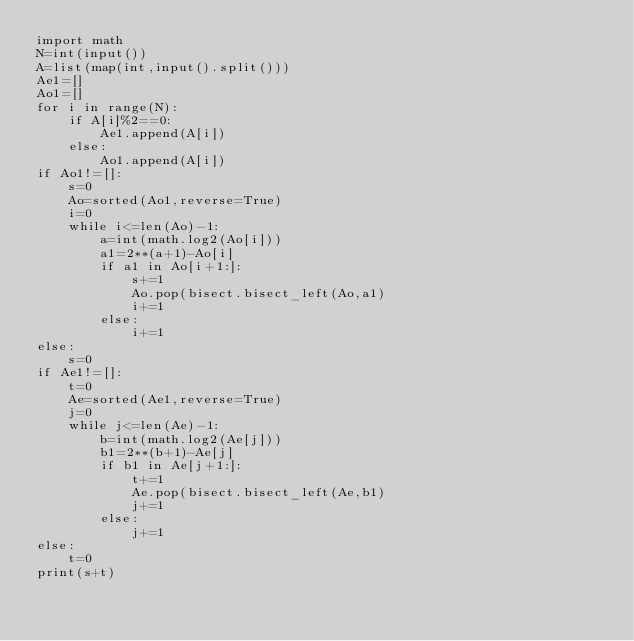<code> <loc_0><loc_0><loc_500><loc_500><_Python_>import math
N=int(input())
A=list(map(int,input().split()))
Ae1=[]
Ao1=[]
for i in range(N):
    if A[i]%2==0:
        Ae1.append(A[i])
    else:
        Ao1.append(A[i])
if Ao1!=[]:
    s=0
    Ao=sorted(Ao1,reverse=True)
    i=0
    while i<=len(Ao)-1:
        a=int(math.log2(Ao[i]))
        a1=2**(a+1)-Ao[i]
        if a1 in Ao[i+1:]:
            s+=1
            Ao.pop(bisect.bisect_left(Ao,a1)
            i+=1
        else:
            i+=1
else:
    s=0
if Ae1!=[]:
    t=0
    Ae=sorted(Ae1,reverse=True)
    j=0
    while j<=len(Ae)-1:
        b=int(math.log2(Ae[j]))
        b1=2**(b+1)-Ae[j]
        if b1 in Ae[j+1:]:
            t+=1
            Ae.pop(bisect.bisect_left(Ae,b1)
            j+=1
        else:
            j+=1
else:
    t=0
print(s+t)</code> 